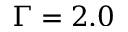Convert formula to latex. <formula><loc_0><loc_0><loc_500><loc_500>\Gamma = 2 . 0</formula> 